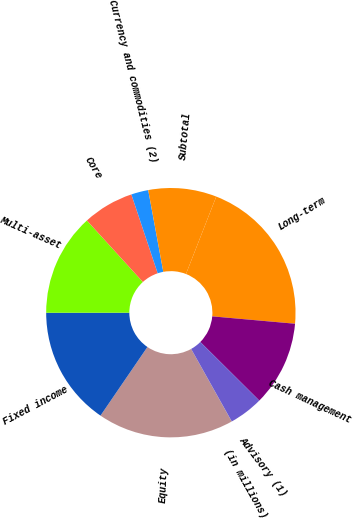Convert chart. <chart><loc_0><loc_0><loc_500><loc_500><pie_chart><fcel>(in millions)<fcel>Equity<fcel>Fixed income<fcel>Multi-asset<fcel>Core<fcel>Currency and commodities (2)<fcel>Subtotal<fcel>Long-term<fcel>Cash management<fcel>Advisory (1)<nl><fcel>0.01%<fcel>17.66%<fcel>15.45%<fcel>13.25%<fcel>6.63%<fcel>2.22%<fcel>8.84%<fcel>20.48%<fcel>11.04%<fcel>4.42%<nl></chart> 